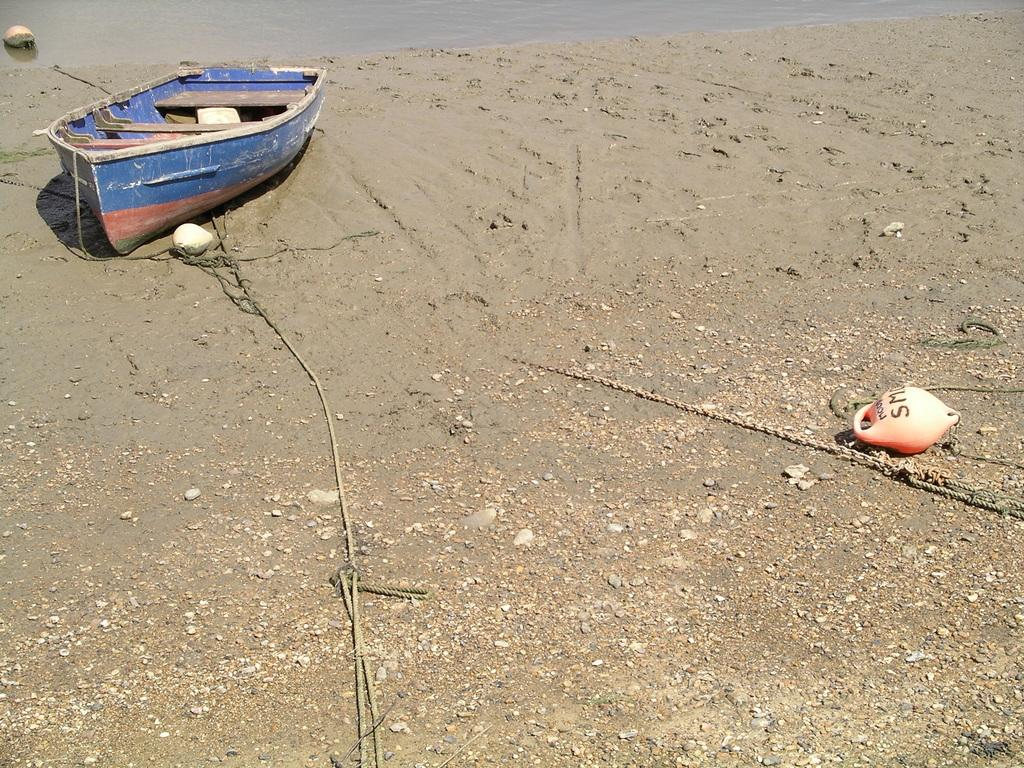<image>
Offer a succinct explanation of the picture presented. An orange buoy with the letters SM on it lies on the beach near a row boat. 